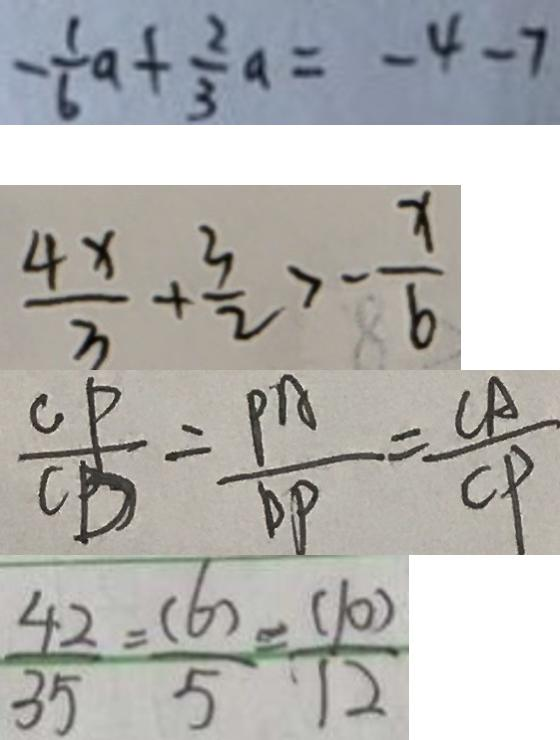<formula> <loc_0><loc_0><loc_500><loc_500>- \frac { 1 } { 6 } a + \frac { 2 } { 3 } a = - 4 - 7 
 \frac { 4 x } { 3 } + \frac { 3 } { 2 } > - \frac { x } { 6 } 
 \frac { C P } { C D } = \frac { P A } { D P } = \frac { C A } { C P } 
 \frac { 4 2 } { 3 5 } = \frac { ( 6 ) } { 5 } = \frac { ( 1 0 ) } { 1 2 }</formula> 